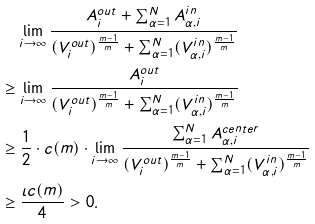<formula> <loc_0><loc_0><loc_500><loc_500>& \quad \lim _ { i \to \infty } \frac { A _ { i } ^ { o u t } + \sum _ { \alpha = 1 } ^ { N } A _ { \alpha , i } ^ { i n } } { ( { V _ { i } ^ { o u t } } ) ^ { \frac { m - 1 } { m } } + \sum _ { \alpha = 1 } ^ { N } ( V _ { \alpha , i } ^ { i n } ) ^ { \frac { m - 1 } { m } } } \\ & \geq \lim _ { i \to \infty } \frac { A _ { i } ^ { o u t } } { ( { V _ { i } ^ { o u t } } ) ^ { \frac { m - 1 } { m } } + \sum _ { \alpha = 1 } ^ { N } ( V _ { \alpha , i } ^ { i n } ) ^ { \frac { m - 1 } { m } } } \\ & \geq \frac { 1 } { 2 } \cdot c ( m ) \cdot \lim _ { i \to \infty } \frac { \sum _ { \alpha = 1 } ^ { N } A _ { \alpha , i } ^ { c e n t e r } } { ( V _ { i } ^ { o u t } ) ^ { \frac { m - 1 } { m } } + \sum _ { \alpha = 1 } ^ { N } ( V _ { \alpha , i } ^ { i n } ) ^ { \frac { m - 1 } { m } } } \\ & \geq \frac { \iota c ( m ) } { 4 } > 0 .</formula> 